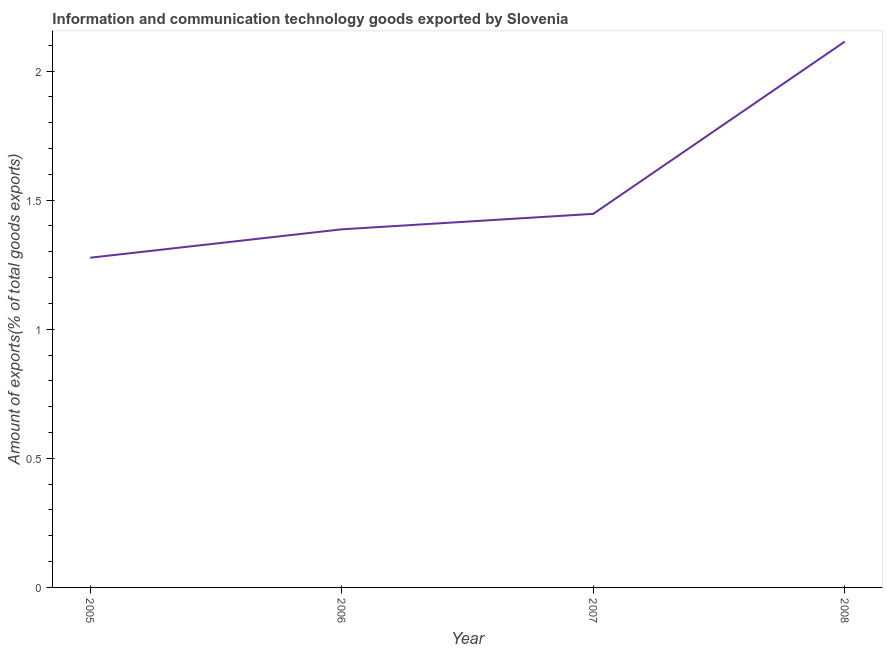What is the amount of ict goods exports in 2007?
Ensure brevity in your answer.  1.45. Across all years, what is the maximum amount of ict goods exports?
Your answer should be compact. 2.11. Across all years, what is the minimum amount of ict goods exports?
Give a very brief answer. 1.28. What is the sum of the amount of ict goods exports?
Ensure brevity in your answer.  6.22. What is the difference between the amount of ict goods exports in 2005 and 2008?
Provide a succinct answer. -0.84. What is the average amount of ict goods exports per year?
Make the answer very short. 1.56. What is the median amount of ict goods exports?
Your answer should be very brief. 1.42. In how many years, is the amount of ict goods exports greater than 0.6 %?
Offer a very short reply. 4. What is the ratio of the amount of ict goods exports in 2005 to that in 2008?
Your answer should be very brief. 0.6. Is the difference between the amount of ict goods exports in 2006 and 2008 greater than the difference between any two years?
Ensure brevity in your answer.  No. What is the difference between the highest and the second highest amount of ict goods exports?
Ensure brevity in your answer.  0.67. Is the sum of the amount of ict goods exports in 2007 and 2008 greater than the maximum amount of ict goods exports across all years?
Ensure brevity in your answer.  Yes. What is the difference between the highest and the lowest amount of ict goods exports?
Your response must be concise. 0.84. How many lines are there?
Give a very brief answer. 1. What is the difference between two consecutive major ticks on the Y-axis?
Offer a terse response. 0.5. Does the graph contain any zero values?
Make the answer very short. No. Does the graph contain grids?
Provide a short and direct response. No. What is the title of the graph?
Provide a short and direct response. Information and communication technology goods exported by Slovenia. What is the label or title of the X-axis?
Keep it short and to the point. Year. What is the label or title of the Y-axis?
Make the answer very short. Amount of exports(% of total goods exports). What is the Amount of exports(% of total goods exports) of 2005?
Your response must be concise. 1.28. What is the Amount of exports(% of total goods exports) of 2006?
Your response must be concise. 1.39. What is the Amount of exports(% of total goods exports) in 2007?
Keep it short and to the point. 1.45. What is the Amount of exports(% of total goods exports) in 2008?
Your answer should be compact. 2.11. What is the difference between the Amount of exports(% of total goods exports) in 2005 and 2006?
Your answer should be compact. -0.11. What is the difference between the Amount of exports(% of total goods exports) in 2005 and 2007?
Make the answer very short. -0.17. What is the difference between the Amount of exports(% of total goods exports) in 2005 and 2008?
Your answer should be very brief. -0.84. What is the difference between the Amount of exports(% of total goods exports) in 2006 and 2007?
Your answer should be very brief. -0.06. What is the difference between the Amount of exports(% of total goods exports) in 2006 and 2008?
Your answer should be very brief. -0.73. What is the difference between the Amount of exports(% of total goods exports) in 2007 and 2008?
Keep it short and to the point. -0.67. What is the ratio of the Amount of exports(% of total goods exports) in 2005 to that in 2006?
Provide a short and direct response. 0.92. What is the ratio of the Amount of exports(% of total goods exports) in 2005 to that in 2007?
Your response must be concise. 0.88. What is the ratio of the Amount of exports(% of total goods exports) in 2005 to that in 2008?
Offer a terse response. 0.6. What is the ratio of the Amount of exports(% of total goods exports) in 2006 to that in 2007?
Your answer should be very brief. 0.96. What is the ratio of the Amount of exports(% of total goods exports) in 2006 to that in 2008?
Make the answer very short. 0.66. What is the ratio of the Amount of exports(% of total goods exports) in 2007 to that in 2008?
Provide a short and direct response. 0.68. 